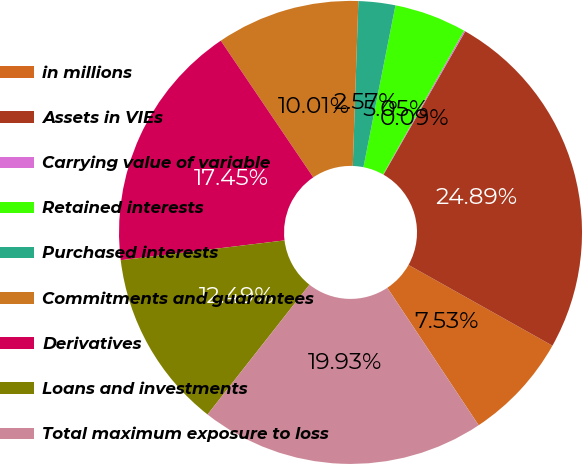Convert chart. <chart><loc_0><loc_0><loc_500><loc_500><pie_chart><fcel>in millions<fcel>Assets in VIEs<fcel>Carrying value of variable<fcel>Retained interests<fcel>Purchased interests<fcel>Commitments and guarantees<fcel>Derivatives<fcel>Loans and investments<fcel>Total maximum exposure to loss<nl><fcel>7.53%<fcel>24.89%<fcel>0.09%<fcel>5.05%<fcel>2.57%<fcel>10.01%<fcel>17.45%<fcel>12.49%<fcel>19.93%<nl></chart> 